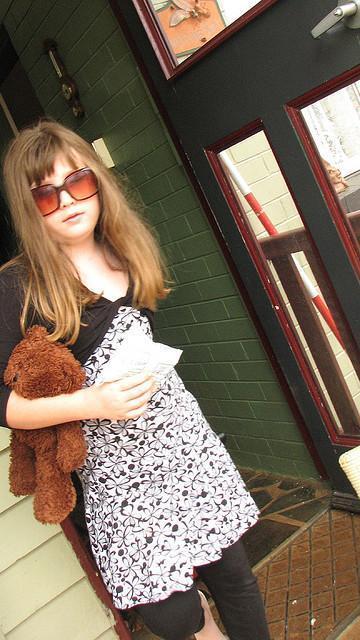How many people can you see?
Give a very brief answer. 1. 